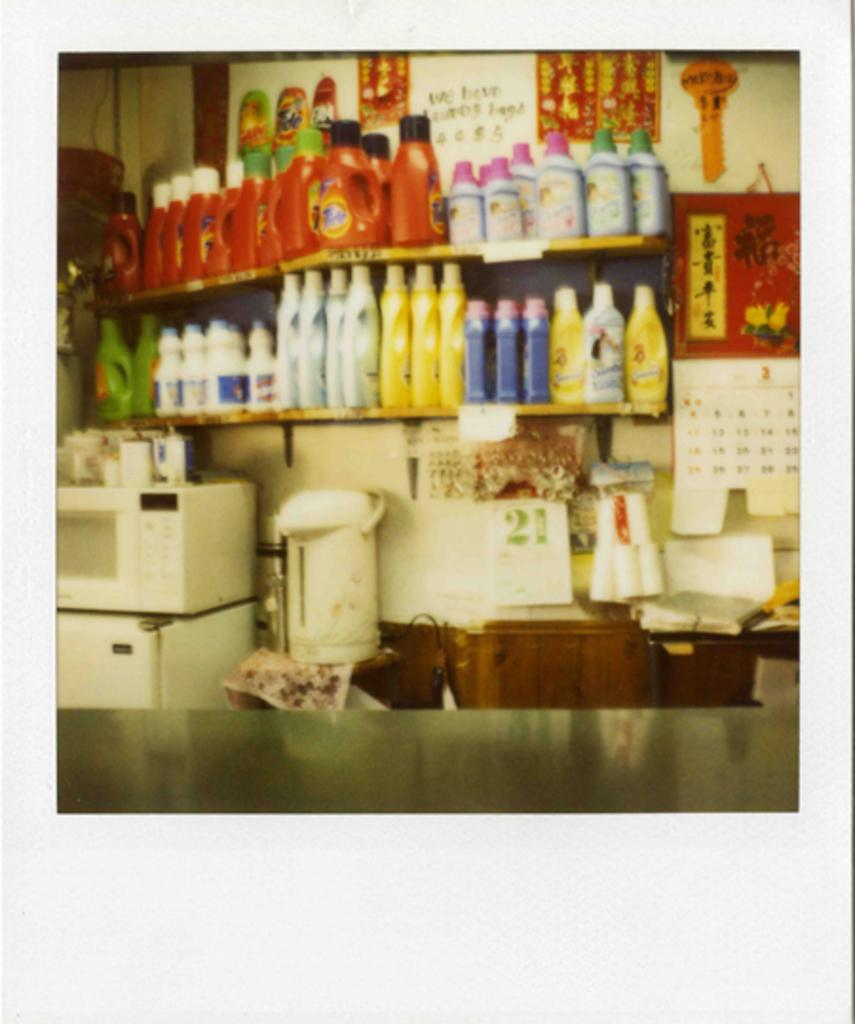<image>
Present a compact description of the photo's key features. Store with a shelf that shows laundry detergent including one that is Tide. 